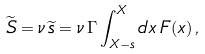<formula> <loc_0><loc_0><loc_500><loc_500>\widetilde { S } = \nu \, \widetilde { s } = \nu \, \Gamma \int _ { X - s } ^ { X } d x \, F ( x ) \, ,</formula> 